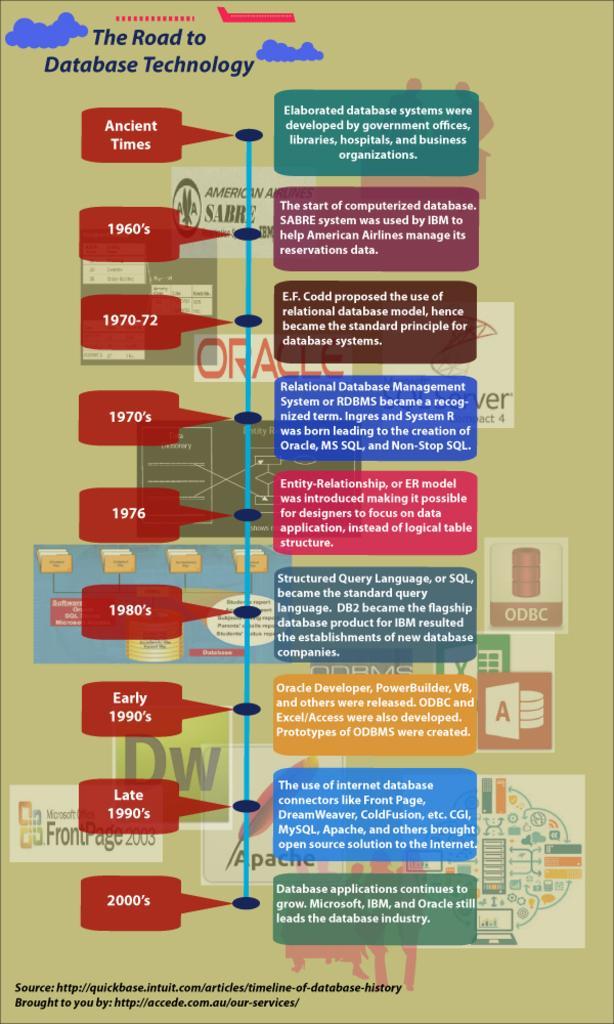Describe this image in one or two sentences. In this image, we can see evolution of database technology. 